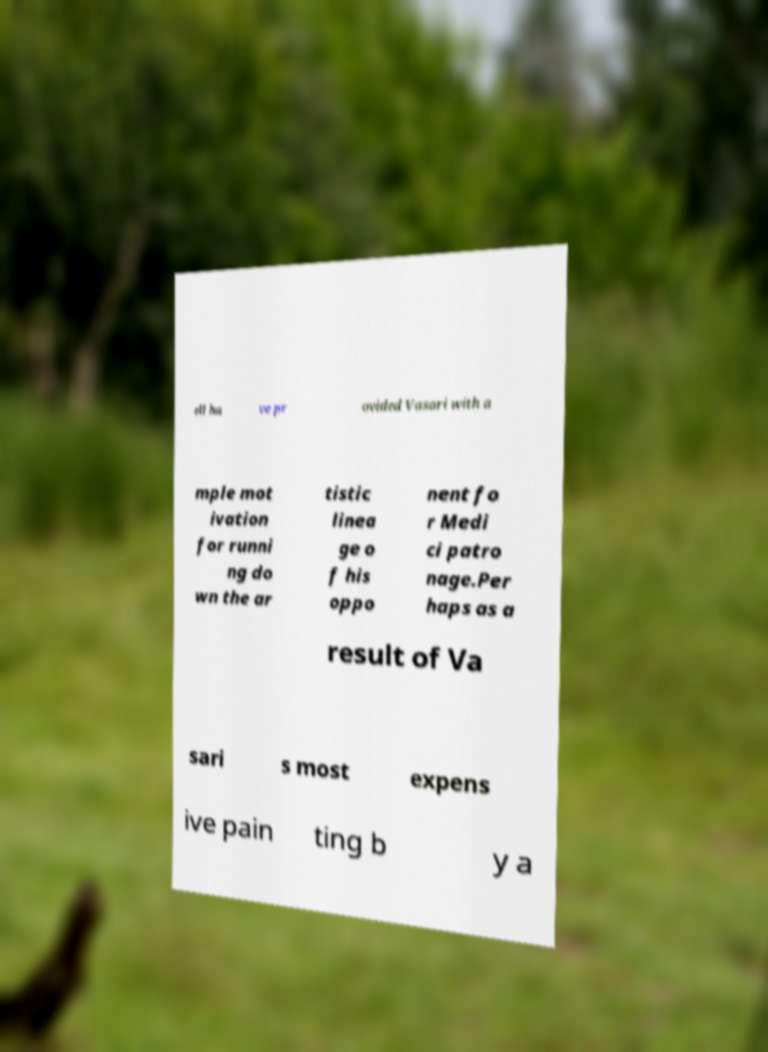Can you read and provide the text displayed in the image?This photo seems to have some interesting text. Can you extract and type it out for me? ell ha ve pr ovided Vasari with a mple mot ivation for runni ng do wn the ar tistic linea ge o f his oppo nent fo r Medi ci patro nage.Per haps as a result of Va sari s most expens ive pain ting b y a 